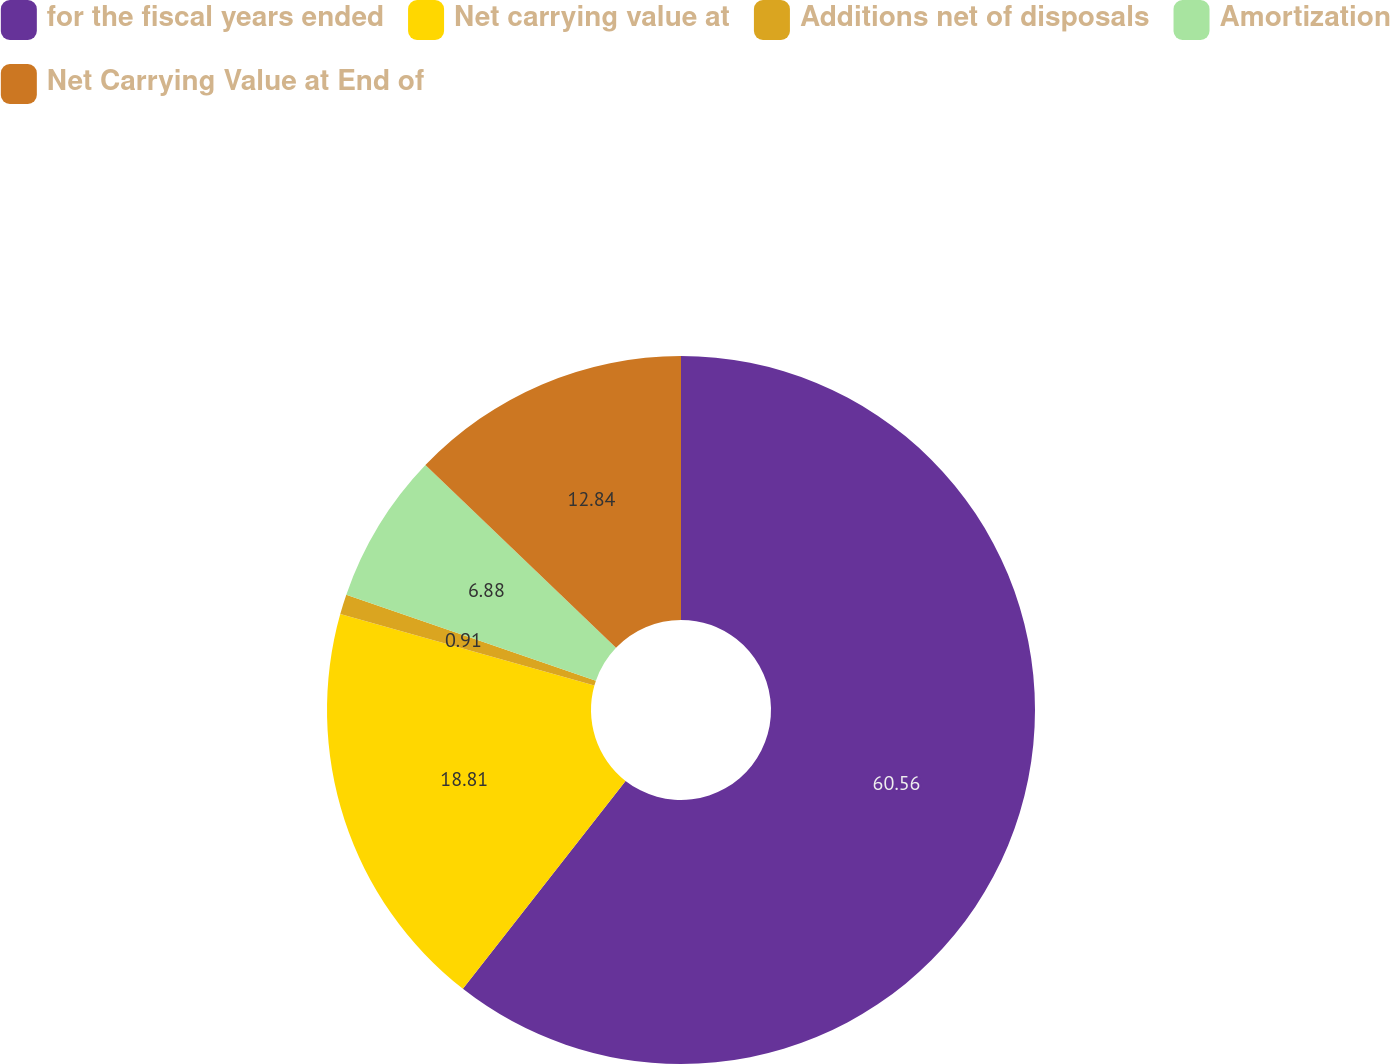<chart> <loc_0><loc_0><loc_500><loc_500><pie_chart><fcel>for the fiscal years ended<fcel>Net carrying value at<fcel>Additions net of disposals<fcel>Amortization<fcel>Net Carrying Value at End of<nl><fcel>60.57%<fcel>18.81%<fcel>0.91%<fcel>6.88%<fcel>12.84%<nl></chart> 